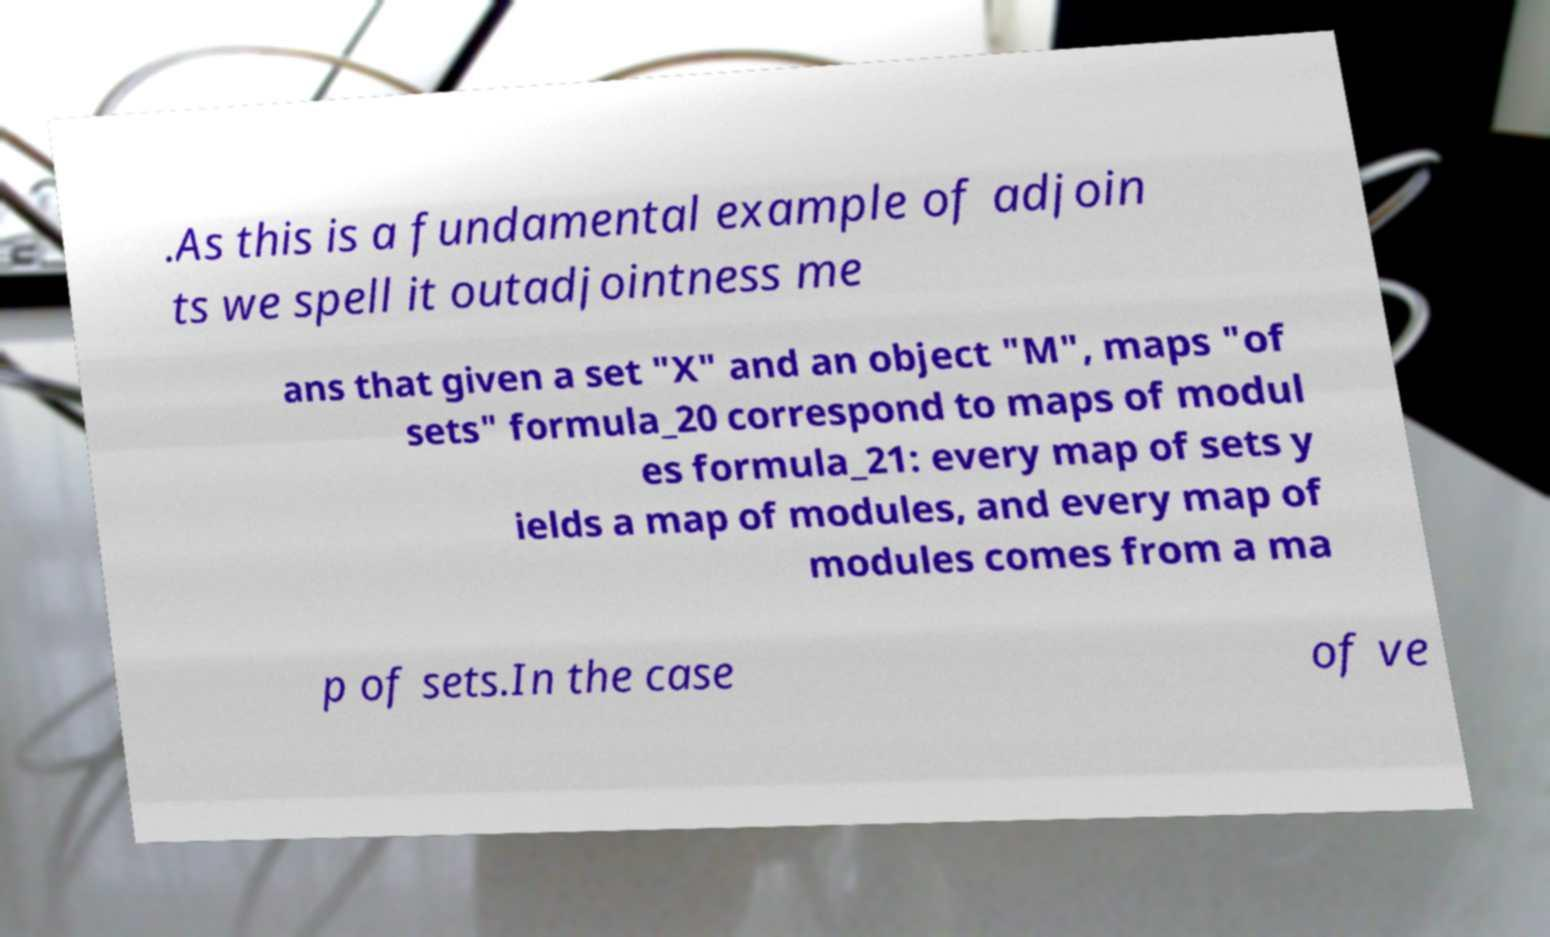Please identify and transcribe the text found in this image. .As this is a fundamental example of adjoin ts we spell it outadjointness me ans that given a set "X" and an object "M", maps "of sets" formula_20 correspond to maps of modul es formula_21: every map of sets y ields a map of modules, and every map of modules comes from a ma p of sets.In the case of ve 